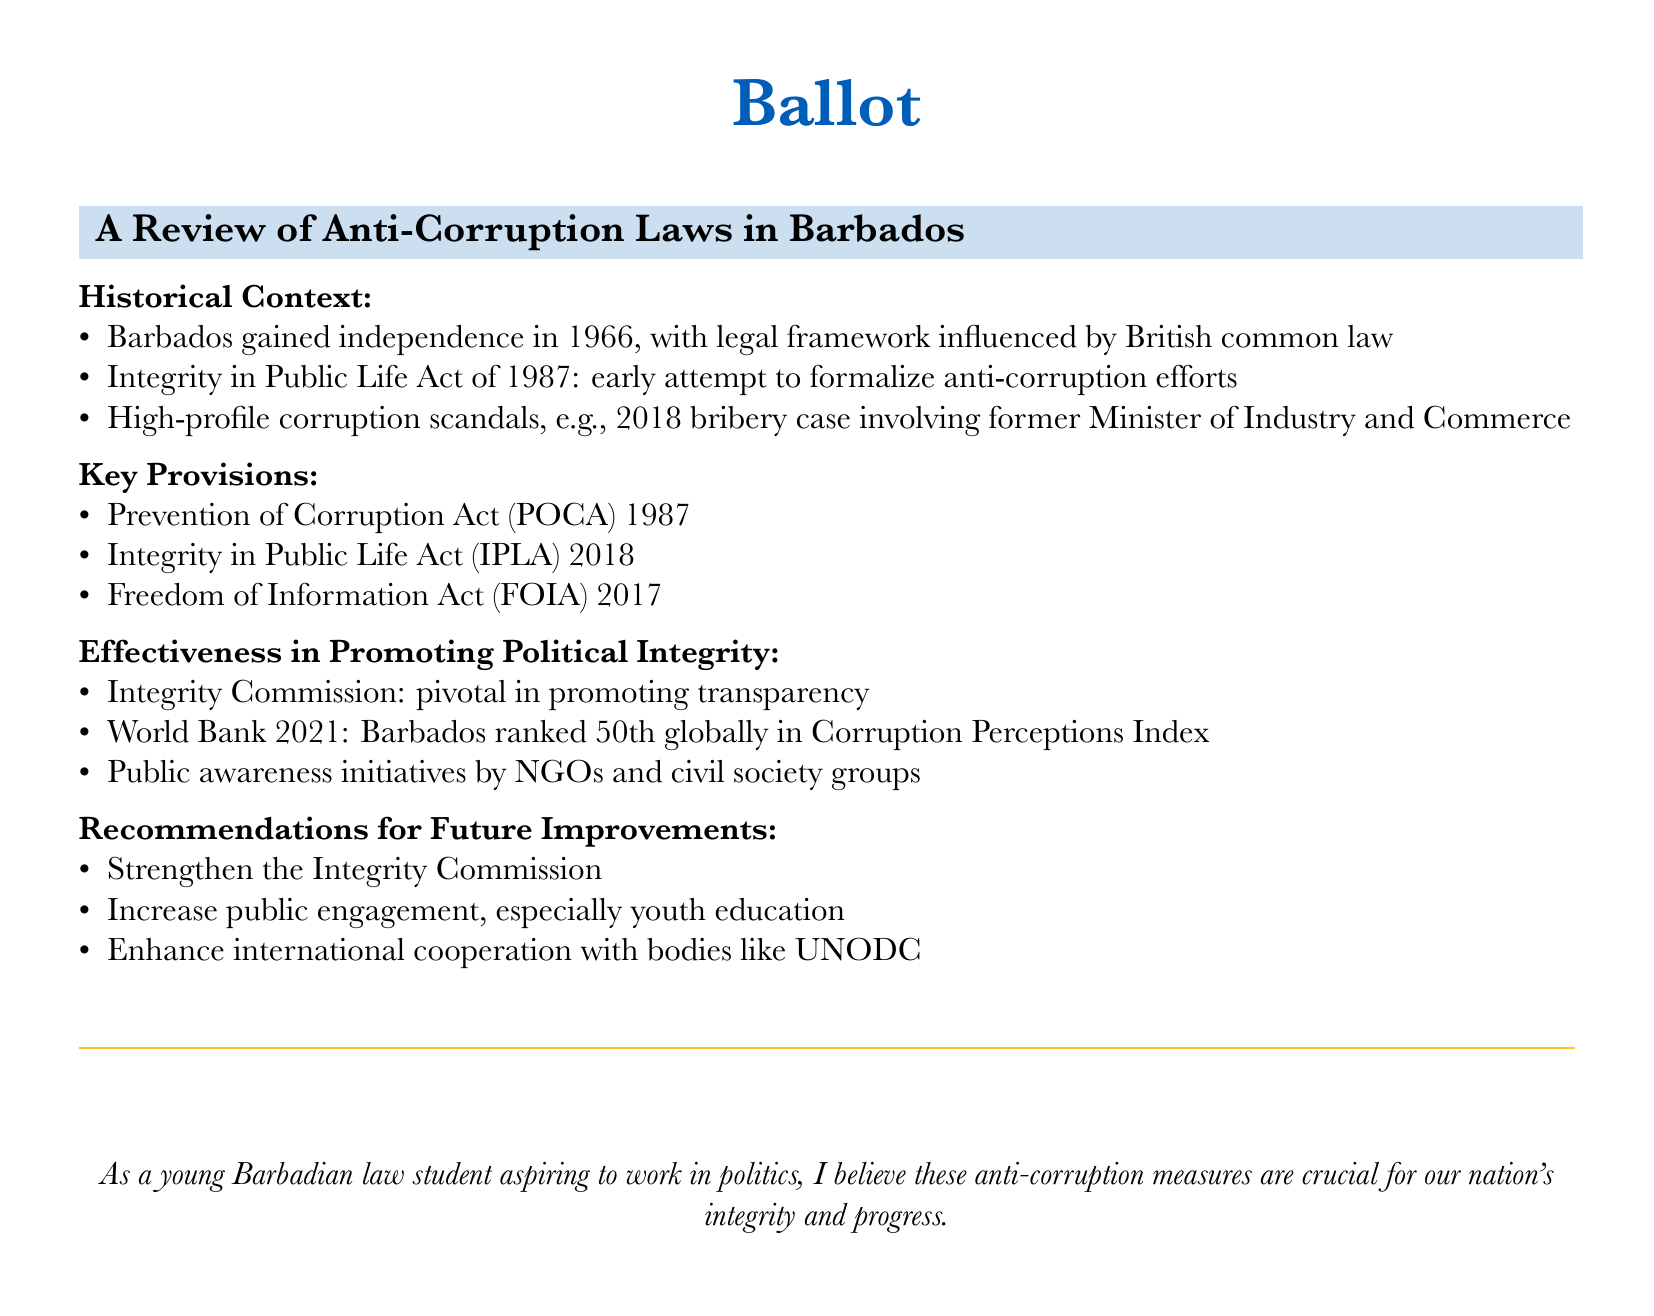what year did Barbados gain independence? The document states that Barbados gained independence in 1966.
Answer: 1966 what is the name of the act introduced in 1987 to formalize anti-corruption efforts? The document mentions the Integrity in Public Life Act was an early attempt introduced in 1987.
Answer: Integrity in Public Life Act which act was enacted in 2018? The document lists the Integrity in Public Life Act as one of the key provisions enacted in 2018.
Answer: Integrity in Public Life Act what ranking did Barbados achieve in the 2021 Corruption Perceptions Index? According to the document, Barbados was ranked 50th globally in the Corruption Perceptions Index.
Answer: 50th what is one recommendation for future improvements mentioned in the document? The document suggests strengthening the Integrity Commission as a recommendation for future improvements.
Answer: Strengthen the Integrity Commission which organization is mentioned for enhancing international cooperation? The document mentions the UNODC as a body for enhancing international cooperation.
Answer: UNODC who is pivotal in promoting transparency according to the document? The document states that the Integrity Commission is pivotal in promoting transparency.
Answer: Integrity Commission what year was the Freedom of Information Act enacted? The document indicates that the Freedom of Information Act was enacted in 2017.
Answer: 2017 